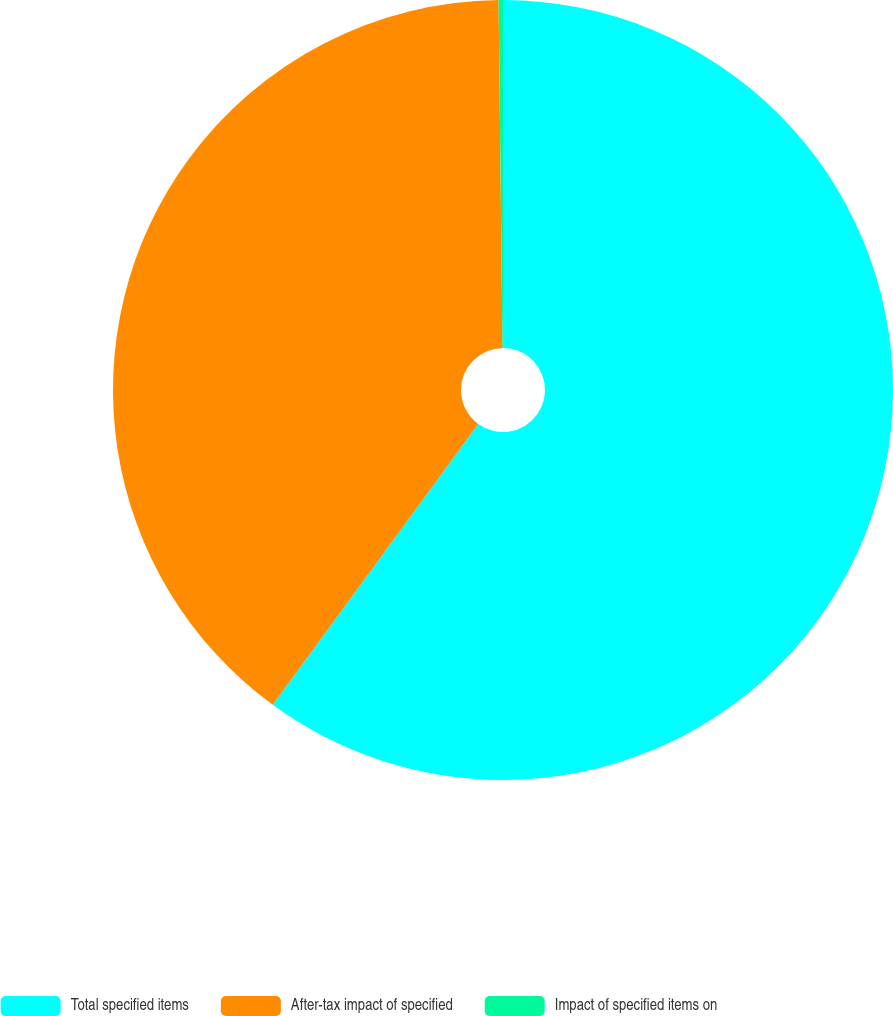<chart> <loc_0><loc_0><loc_500><loc_500><pie_chart><fcel>Total specified items<fcel>After-tax impact of specified<fcel>Impact of specified items on<nl><fcel>60.05%<fcel>39.77%<fcel>0.18%<nl></chart> 